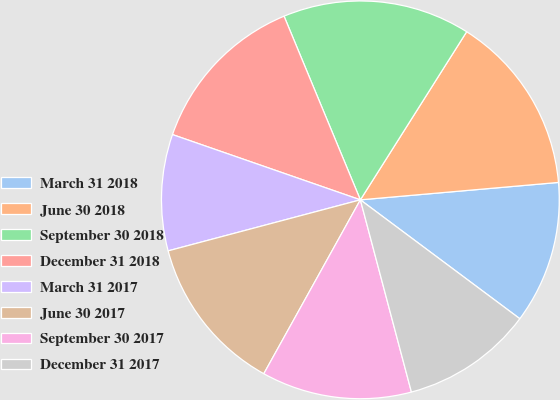Convert chart. <chart><loc_0><loc_0><loc_500><loc_500><pie_chart><fcel>March 31 2018<fcel>June 30 2018<fcel>September 30 2018<fcel>December 31 2018<fcel>March 31 2017<fcel>June 30 2017<fcel>September 30 2017<fcel>December 31 2017<nl><fcel>11.59%<fcel>14.63%<fcel>15.24%<fcel>13.41%<fcel>9.45%<fcel>12.8%<fcel>12.2%<fcel>10.67%<nl></chart> 